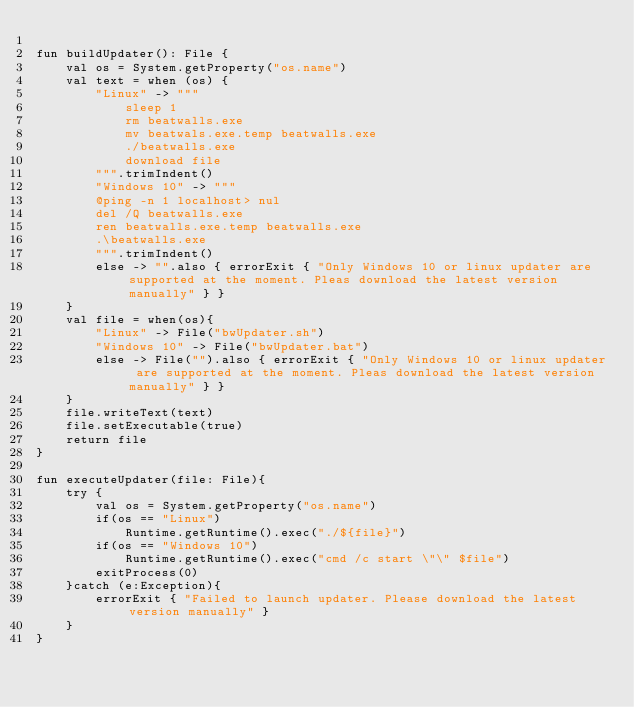Convert code to text. <code><loc_0><loc_0><loc_500><loc_500><_Kotlin_>
fun buildUpdater(): File {
    val os = System.getProperty("os.name")
    val text = when (os) {
        "Linux" -> """
            sleep 1
            rm beatwalls.exe
            mv beatwals.exe.temp beatwalls.exe
            ./beatwalls.exe
            download file
        """.trimIndent()
        "Windows 10" -> """
        @ping -n 1 localhost> nul
        del /Q beatwalls.exe
        ren beatwalls.exe.temp beatwalls.exe
        .\beatwalls.exe
        """.trimIndent()
        else -> "".also { errorExit { "Only Windows 10 or linux updater are supported at the moment. Pleas download the latest version manually" } }
    }
    val file = when(os){
        "Linux" -> File("bwUpdater.sh")
        "Windows 10" -> File("bwUpdater.bat")
        else -> File("").also { errorExit { "Only Windows 10 or linux updater are supported at the moment. Pleas download the latest version manually" } }
    }
    file.writeText(text)
    file.setExecutable(true)
    return file
}

fun executeUpdater(file: File){
    try {
        val os = System.getProperty("os.name")
        if(os == "Linux")
            Runtime.getRuntime().exec("./${file}")
        if(os == "Windows 10")
            Runtime.getRuntime().exec("cmd /c start \"\" $file")
        exitProcess(0)
    }catch (e:Exception){
        errorExit { "Failed to launch updater. Please download the latest version manually" }
    }
}


</code> 